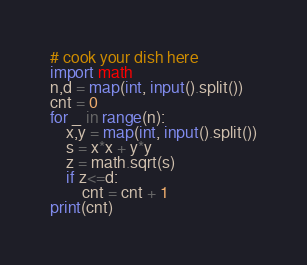Convert code to text. <code><loc_0><loc_0><loc_500><loc_500><_Python_># cook your dish here
import math
n,d = map(int, input().split())
cnt = 0
for _ in range(n):
    x,y = map(int, input().split())
    s = x*x + y*y
    z = math.sqrt(s)
    if z<=d:
        cnt = cnt + 1
print(cnt)</code> 